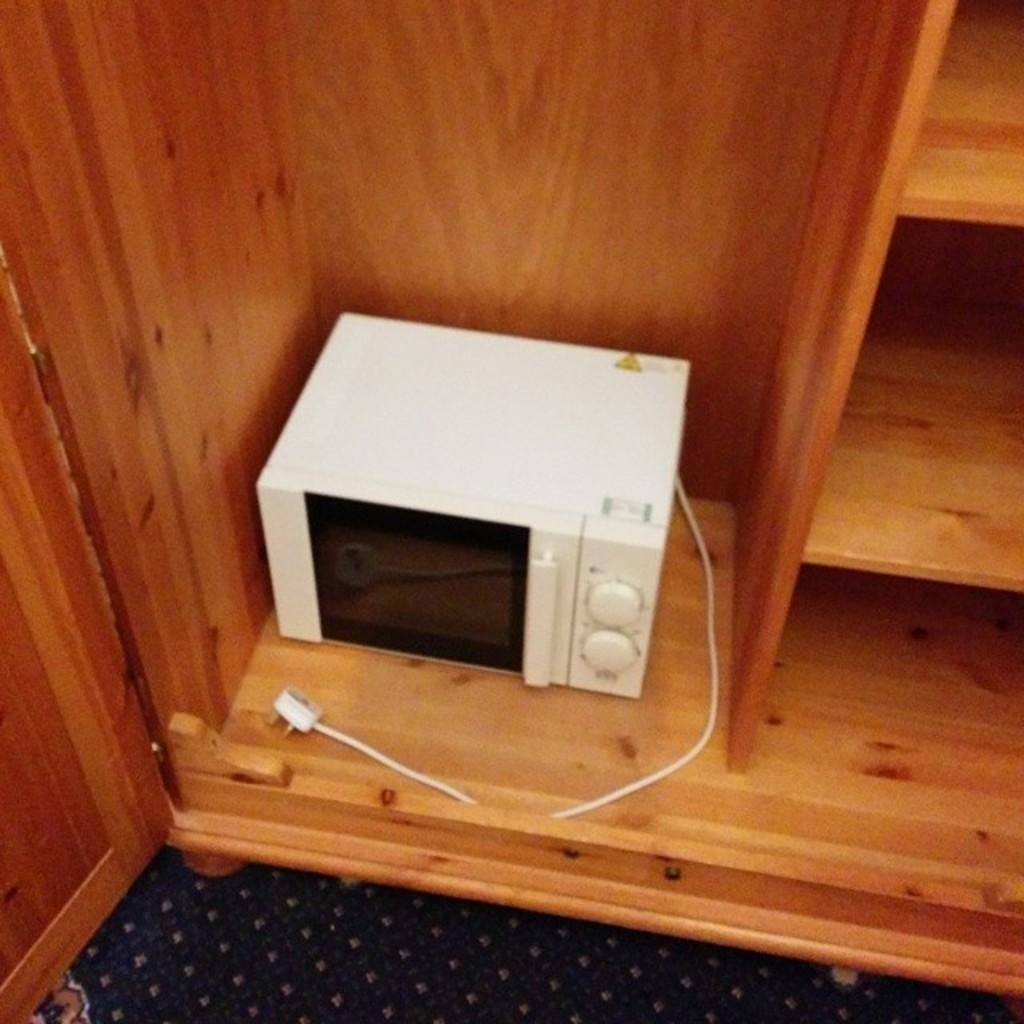What type of appliance can be seen in the image? There is an oven in the image. What else is visible in the image besides the oven? There is a cable, wooden racks, a door, and a floor visible in the image. What might the cable be connected to? The cable might be connected to the oven or another appliance in the image. What is the purpose of the wooden racks in the image? The wooden racks might be used for storage or displaying items. How many eyes can be seen on the cactus in the image? There is no cactus present in the image, so it is not possible to determine the number of eyes on a cactus. 